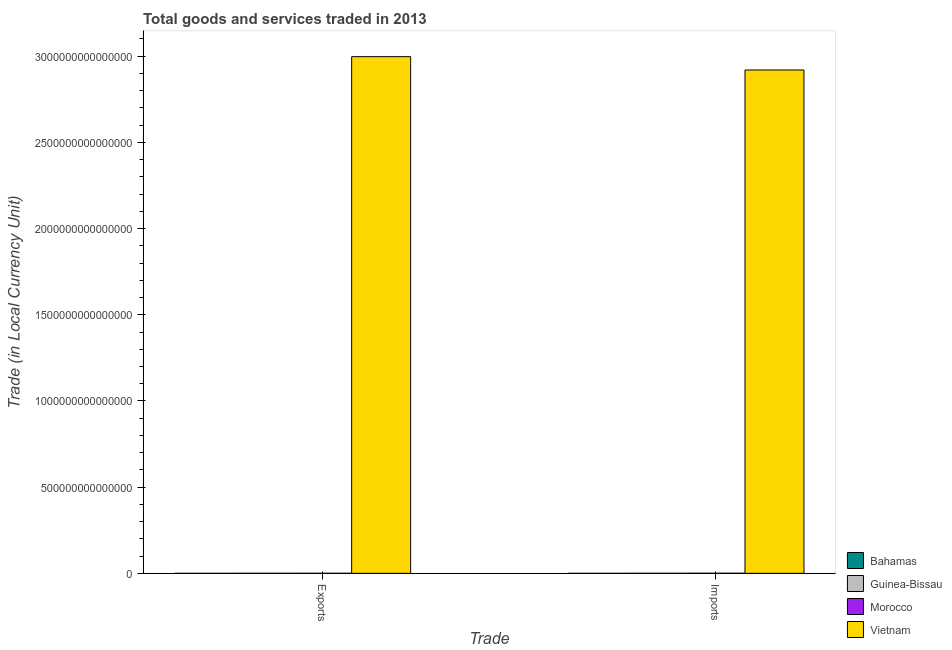How many groups of bars are there?
Provide a short and direct response. 2. Are the number of bars on each tick of the X-axis equal?
Make the answer very short. Yes. How many bars are there on the 1st tick from the left?
Your response must be concise. 4. What is the label of the 2nd group of bars from the left?
Make the answer very short. Imports. What is the export of goods and services in Vietnam?
Offer a very short reply. 3.00e+15. Across all countries, what is the maximum imports of goods and services?
Your response must be concise. 2.92e+15. Across all countries, what is the minimum imports of goods and services?
Ensure brevity in your answer.  4.70e+09. In which country was the imports of goods and services maximum?
Provide a succinct answer. Vietnam. In which country was the export of goods and services minimum?
Your response must be concise. Bahamas. What is the total imports of goods and services in the graph?
Offer a very short reply. 2.92e+15. What is the difference between the export of goods and services in Bahamas and that in Guinea-Bissau?
Keep it short and to the point. -7.80e+1. What is the difference between the imports of goods and services in Guinea-Bissau and the export of goods and services in Vietnam?
Provide a succinct answer. -3.00e+15. What is the average imports of goods and services per country?
Give a very brief answer. 7.30e+14. What is the difference between the export of goods and services and imports of goods and services in Guinea-Bissau?
Offer a terse response. -3.17e+1. In how many countries, is the imports of goods and services greater than 900000000000000 LCU?
Your answer should be compact. 1. What is the ratio of the export of goods and services in Guinea-Bissau to that in Bahamas?
Give a very brief answer. 21.99. Is the export of goods and services in Bahamas less than that in Guinea-Bissau?
Offer a very short reply. Yes. In how many countries, is the export of goods and services greater than the average export of goods and services taken over all countries?
Your answer should be very brief. 1. What does the 1st bar from the left in Exports represents?
Your answer should be compact. Bahamas. What does the 2nd bar from the right in Exports represents?
Keep it short and to the point. Morocco. How many bars are there?
Provide a succinct answer. 8. Are all the bars in the graph horizontal?
Make the answer very short. No. What is the difference between two consecutive major ticks on the Y-axis?
Your response must be concise. 5.00e+14. Does the graph contain any zero values?
Give a very brief answer. No. What is the title of the graph?
Your answer should be very brief. Total goods and services traded in 2013. What is the label or title of the X-axis?
Keep it short and to the point. Trade. What is the label or title of the Y-axis?
Make the answer very short. Trade (in Local Currency Unit). What is the Trade (in Local Currency Unit) in Bahamas in Exports?
Provide a short and direct response. 3.72e+09. What is the Trade (in Local Currency Unit) of Guinea-Bissau in Exports?
Keep it short and to the point. 8.17e+1. What is the Trade (in Local Currency Unit) of Morocco in Exports?
Ensure brevity in your answer.  2.94e+11. What is the Trade (in Local Currency Unit) in Vietnam in Exports?
Give a very brief answer. 3.00e+15. What is the Trade (in Local Currency Unit) of Bahamas in Imports?
Provide a short and direct response. 4.70e+09. What is the Trade (in Local Currency Unit) in Guinea-Bissau in Imports?
Provide a short and direct response. 1.13e+11. What is the Trade (in Local Currency Unit) of Morocco in Imports?
Give a very brief answer. 4.24e+11. What is the Trade (in Local Currency Unit) in Vietnam in Imports?
Ensure brevity in your answer.  2.92e+15. Across all Trade, what is the maximum Trade (in Local Currency Unit) in Bahamas?
Give a very brief answer. 4.70e+09. Across all Trade, what is the maximum Trade (in Local Currency Unit) in Guinea-Bissau?
Ensure brevity in your answer.  1.13e+11. Across all Trade, what is the maximum Trade (in Local Currency Unit) in Morocco?
Your answer should be very brief. 4.24e+11. Across all Trade, what is the maximum Trade (in Local Currency Unit) of Vietnam?
Give a very brief answer. 3.00e+15. Across all Trade, what is the minimum Trade (in Local Currency Unit) in Bahamas?
Provide a short and direct response. 3.72e+09. Across all Trade, what is the minimum Trade (in Local Currency Unit) of Guinea-Bissau?
Offer a terse response. 8.17e+1. Across all Trade, what is the minimum Trade (in Local Currency Unit) in Morocco?
Ensure brevity in your answer.  2.94e+11. Across all Trade, what is the minimum Trade (in Local Currency Unit) in Vietnam?
Keep it short and to the point. 2.92e+15. What is the total Trade (in Local Currency Unit) of Bahamas in the graph?
Ensure brevity in your answer.  8.42e+09. What is the total Trade (in Local Currency Unit) in Guinea-Bissau in the graph?
Your answer should be very brief. 1.95e+11. What is the total Trade (in Local Currency Unit) in Morocco in the graph?
Keep it short and to the point. 7.19e+11. What is the total Trade (in Local Currency Unit) in Vietnam in the graph?
Provide a short and direct response. 5.92e+15. What is the difference between the Trade (in Local Currency Unit) of Bahamas in Exports and that in Imports?
Offer a very short reply. -9.86e+08. What is the difference between the Trade (in Local Currency Unit) of Guinea-Bissau in Exports and that in Imports?
Offer a terse response. -3.17e+1. What is the difference between the Trade (in Local Currency Unit) of Morocco in Exports and that in Imports?
Make the answer very short. -1.30e+11. What is the difference between the Trade (in Local Currency Unit) of Vietnam in Exports and that in Imports?
Give a very brief answer. 7.74e+13. What is the difference between the Trade (in Local Currency Unit) of Bahamas in Exports and the Trade (in Local Currency Unit) of Guinea-Bissau in Imports?
Provide a succinct answer. -1.10e+11. What is the difference between the Trade (in Local Currency Unit) in Bahamas in Exports and the Trade (in Local Currency Unit) in Morocco in Imports?
Provide a short and direct response. -4.20e+11. What is the difference between the Trade (in Local Currency Unit) in Bahamas in Exports and the Trade (in Local Currency Unit) in Vietnam in Imports?
Keep it short and to the point. -2.92e+15. What is the difference between the Trade (in Local Currency Unit) of Guinea-Bissau in Exports and the Trade (in Local Currency Unit) of Morocco in Imports?
Ensure brevity in your answer.  -3.43e+11. What is the difference between the Trade (in Local Currency Unit) in Guinea-Bissau in Exports and the Trade (in Local Currency Unit) in Vietnam in Imports?
Your response must be concise. -2.92e+15. What is the difference between the Trade (in Local Currency Unit) in Morocco in Exports and the Trade (in Local Currency Unit) in Vietnam in Imports?
Offer a terse response. -2.92e+15. What is the average Trade (in Local Currency Unit) of Bahamas per Trade?
Your answer should be compact. 4.21e+09. What is the average Trade (in Local Currency Unit) in Guinea-Bissau per Trade?
Keep it short and to the point. 9.76e+1. What is the average Trade (in Local Currency Unit) in Morocco per Trade?
Make the answer very short. 3.59e+11. What is the average Trade (in Local Currency Unit) in Vietnam per Trade?
Provide a succinct answer. 2.96e+15. What is the difference between the Trade (in Local Currency Unit) of Bahamas and Trade (in Local Currency Unit) of Guinea-Bissau in Exports?
Your answer should be very brief. -7.80e+1. What is the difference between the Trade (in Local Currency Unit) of Bahamas and Trade (in Local Currency Unit) of Morocco in Exports?
Make the answer very short. -2.91e+11. What is the difference between the Trade (in Local Currency Unit) of Bahamas and Trade (in Local Currency Unit) of Vietnam in Exports?
Ensure brevity in your answer.  -3.00e+15. What is the difference between the Trade (in Local Currency Unit) in Guinea-Bissau and Trade (in Local Currency Unit) in Morocco in Exports?
Give a very brief answer. -2.13e+11. What is the difference between the Trade (in Local Currency Unit) of Guinea-Bissau and Trade (in Local Currency Unit) of Vietnam in Exports?
Your response must be concise. -3.00e+15. What is the difference between the Trade (in Local Currency Unit) in Morocco and Trade (in Local Currency Unit) in Vietnam in Exports?
Keep it short and to the point. -3.00e+15. What is the difference between the Trade (in Local Currency Unit) in Bahamas and Trade (in Local Currency Unit) in Guinea-Bissau in Imports?
Your response must be concise. -1.09e+11. What is the difference between the Trade (in Local Currency Unit) of Bahamas and Trade (in Local Currency Unit) of Morocco in Imports?
Give a very brief answer. -4.20e+11. What is the difference between the Trade (in Local Currency Unit) of Bahamas and Trade (in Local Currency Unit) of Vietnam in Imports?
Give a very brief answer. -2.92e+15. What is the difference between the Trade (in Local Currency Unit) of Guinea-Bissau and Trade (in Local Currency Unit) of Morocco in Imports?
Your answer should be compact. -3.11e+11. What is the difference between the Trade (in Local Currency Unit) in Guinea-Bissau and Trade (in Local Currency Unit) in Vietnam in Imports?
Give a very brief answer. -2.92e+15. What is the difference between the Trade (in Local Currency Unit) of Morocco and Trade (in Local Currency Unit) of Vietnam in Imports?
Provide a short and direct response. -2.92e+15. What is the ratio of the Trade (in Local Currency Unit) of Bahamas in Exports to that in Imports?
Your answer should be compact. 0.79. What is the ratio of the Trade (in Local Currency Unit) in Guinea-Bissau in Exports to that in Imports?
Keep it short and to the point. 0.72. What is the ratio of the Trade (in Local Currency Unit) of Morocco in Exports to that in Imports?
Offer a terse response. 0.69. What is the ratio of the Trade (in Local Currency Unit) of Vietnam in Exports to that in Imports?
Ensure brevity in your answer.  1.03. What is the difference between the highest and the second highest Trade (in Local Currency Unit) in Bahamas?
Ensure brevity in your answer.  9.86e+08. What is the difference between the highest and the second highest Trade (in Local Currency Unit) of Guinea-Bissau?
Offer a terse response. 3.17e+1. What is the difference between the highest and the second highest Trade (in Local Currency Unit) of Morocco?
Make the answer very short. 1.30e+11. What is the difference between the highest and the second highest Trade (in Local Currency Unit) in Vietnam?
Your response must be concise. 7.74e+13. What is the difference between the highest and the lowest Trade (in Local Currency Unit) of Bahamas?
Offer a very short reply. 9.86e+08. What is the difference between the highest and the lowest Trade (in Local Currency Unit) of Guinea-Bissau?
Provide a succinct answer. 3.17e+1. What is the difference between the highest and the lowest Trade (in Local Currency Unit) of Morocco?
Keep it short and to the point. 1.30e+11. What is the difference between the highest and the lowest Trade (in Local Currency Unit) of Vietnam?
Your answer should be very brief. 7.74e+13. 